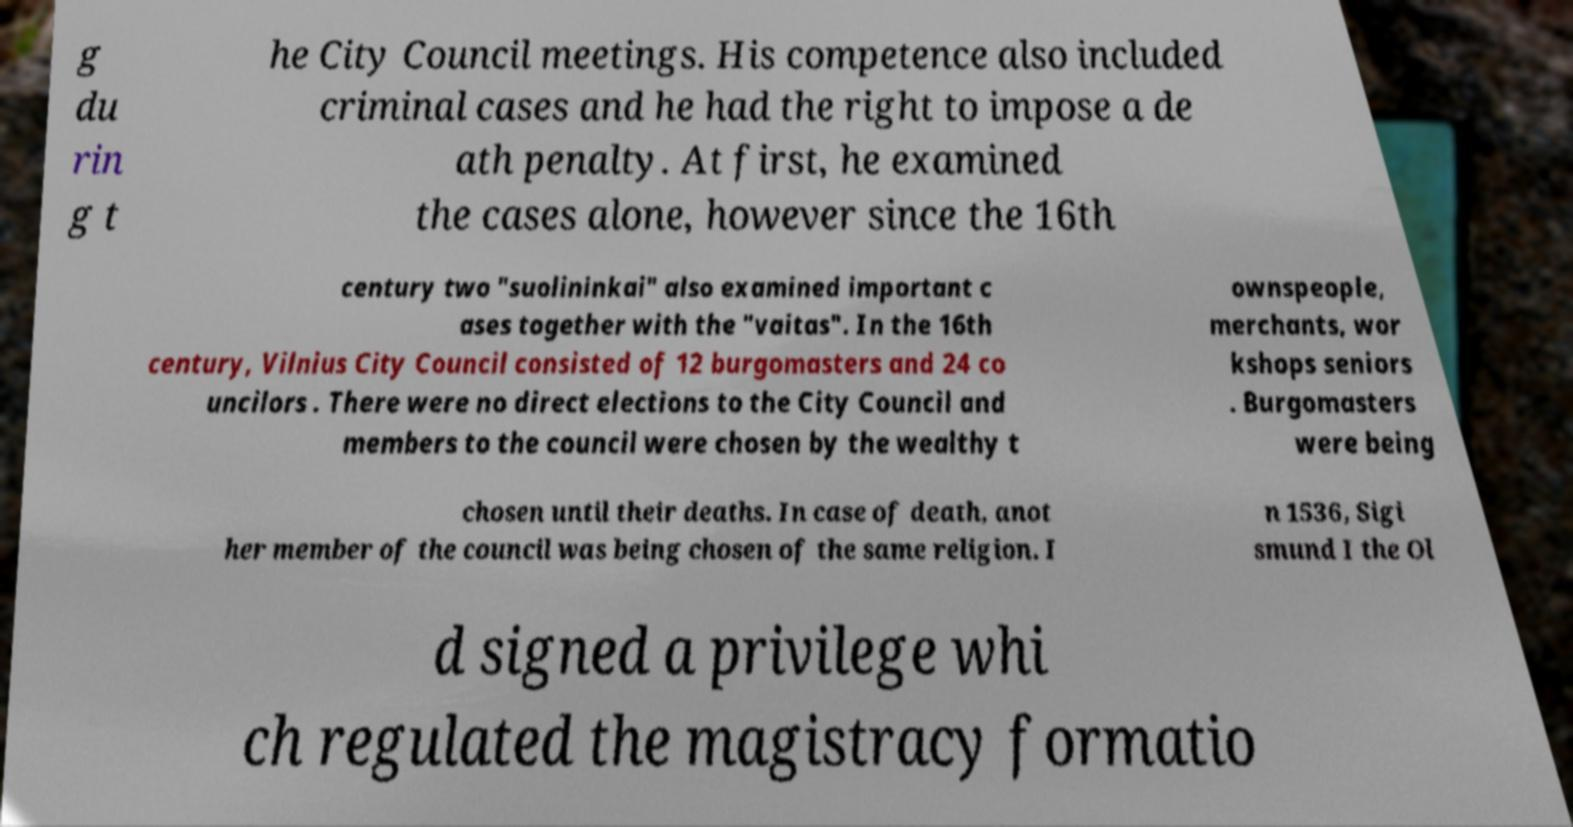Can you accurately transcribe the text from the provided image for me? g du rin g t he City Council meetings. His competence also included criminal cases and he had the right to impose a de ath penalty. At first, he examined the cases alone, however since the 16th century two "suolininkai" also examined important c ases together with the "vaitas". In the 16th century, Vilnius City Council consisted of 12 burgomasters and 24 co uncilors . There were no direct elections to the City Council and members to the council were chosen by the wealthy t ownspeople, merchants, wor kshops seniors . Burgomasters were being chosen until their deaths. In case of death, anot her member of the council was being chosen of the same religion. I n 1536, Sigi smund I the Ol d signed a privilege whi ch regulated the magistracy formatio 